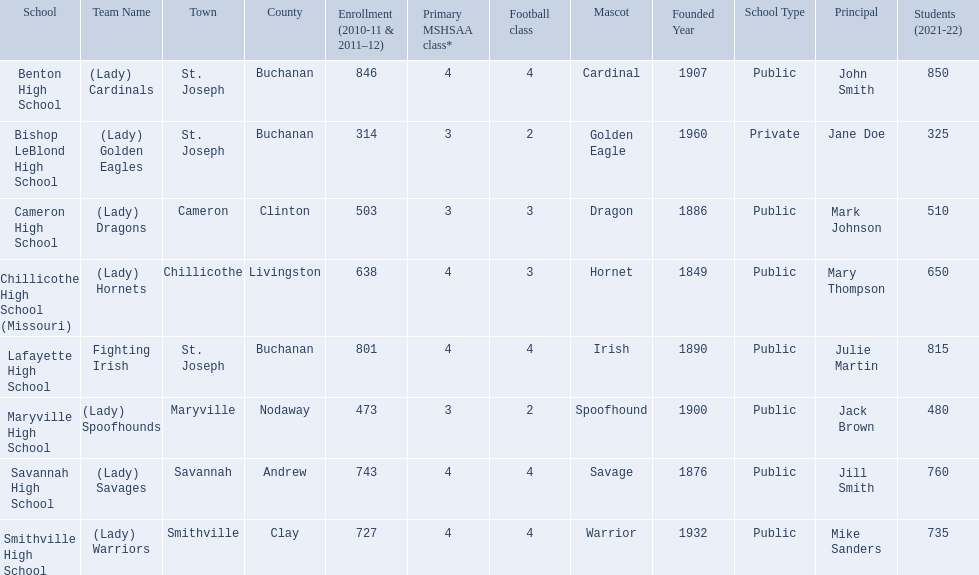What school in midland empire conference has 846 students enrolled? Benton High School. What school has 314 students enrolled? Bishop LeBlond High School. What school had 638 students enrolled? Chillicothe High School (Missouri). 